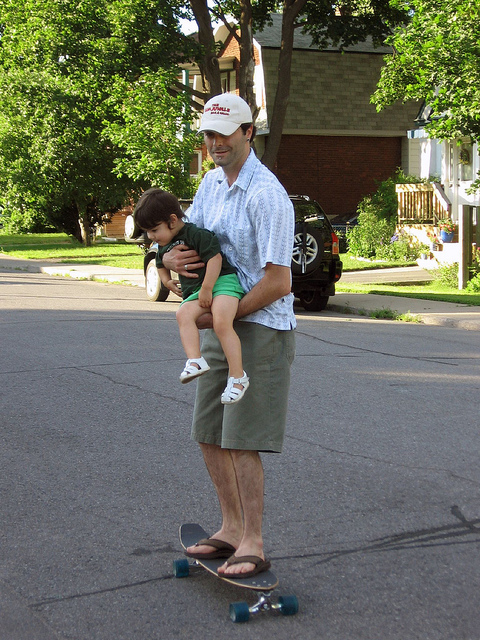<image>What trick is this? I don't know. It can be seen as a trick with a skateboard or no trick at all. What trick is this? I am not sure what trick is being performed. It could be skateboarding or carrying a baby. 